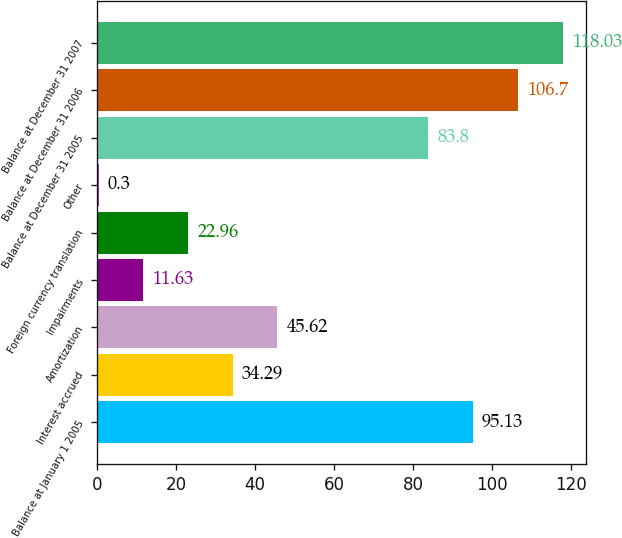Convert chart to OTSL. <chart><loc_0><loc_0><loc_500><loc_500><bar_chart><fcel>Balance at January 1 2005<fcel>Interest accrued<fcel>Amortization<fcel>Impairments<fcel>Foreign currency translation<fcel>Other<fcel>Balance at December 31 2005<fcel>Balance at December 31 2006<fcel>Balance at December 31 2007<nl><fcel>95.13<fcel>34.29<fcel>45.62<fcel>11.63<fcel>22.96<fcel>0.3<fcel>83.8<fcel>106.7<fcel>118.03<nl></chart> 